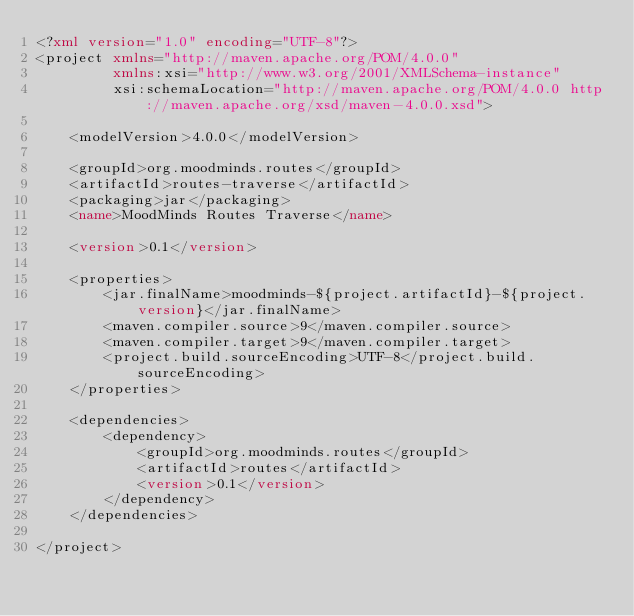<code> <loc_0><loc_0><loc_500><loc_500><_XML_><?xml version="1.0" encoding="UTF-8"?>
<project xmlns="http://maven.apache.org/POM/4.0.0"
         xmlns:xsi="http://www.w3.org/2001/XMLSchema-instance"
         xsi:schemaLocation="http://maven.apache.org/POM/4.0.0 http://maven.apache.org/xsd/maven-4.0.0.xsd">

    <modelVersion>4.0.0</modelVersion>

    <groupId>org.moodminds.routes</groupId>
    <artifactId>routes-traverse</artifactId>
    <packaging>jar</packaging>
    <name>MoodMinds Routes Traverse</name>

    <version>0.1</version>

    <properties>
        <jar.finalName>moodminds-${project.artifactId}-${project.version}</jar.finalName>
        <maven.compiler.source>9</maven.compiler.source>
        <maven.compiler.target>9</maven.compiler.target>
        <project.build.sourceEncoding>UTF-8</project.build.sourceEncoding>
    </properties>

    <dependencies>
        <dependency>
            <groupId>org.moodminds.routes</groupId>
            <artifactId>routes</artifactId>
            <version>0.1</version>
        </dependency>
    </dependencies>

</project></code> 